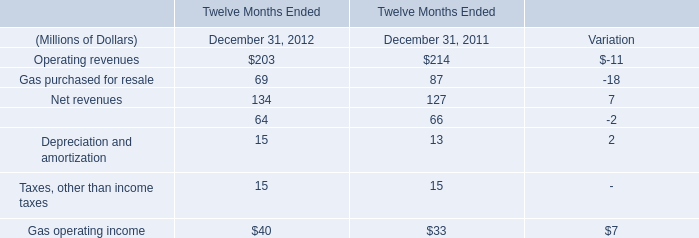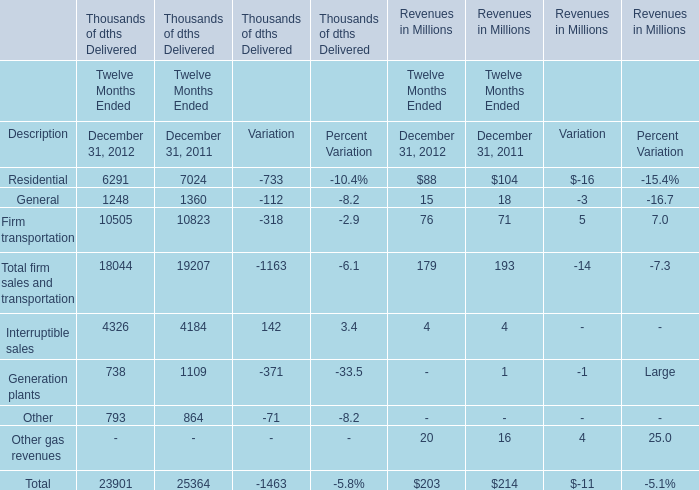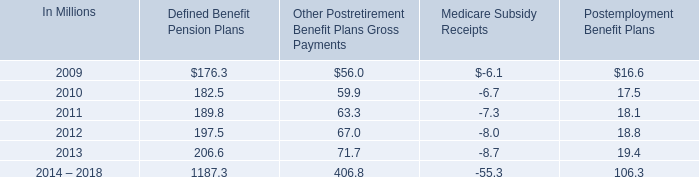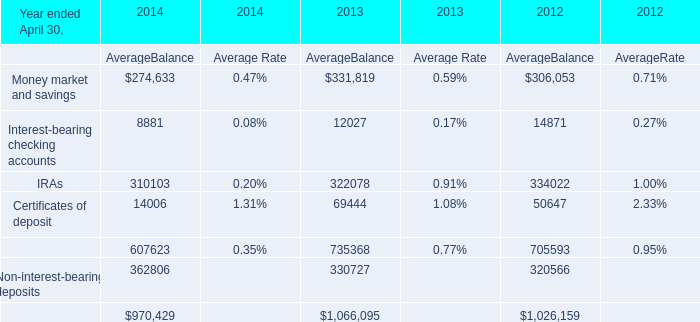In the year/section with the most Operating revenues, what is the growth rate of Gas operating income? 
Computations: (7 / 33)
Answer: 0.21212. 